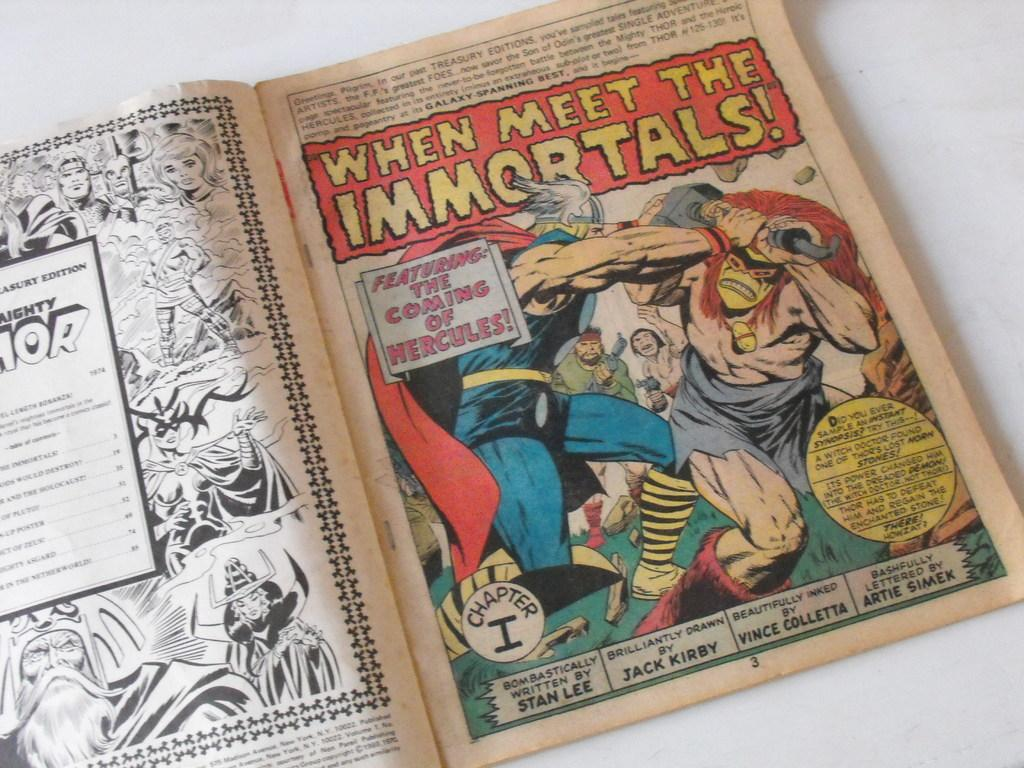<image>
Describe the image concisely. A comic book is opened at the title page of a strip called When Meet The Immortals. 